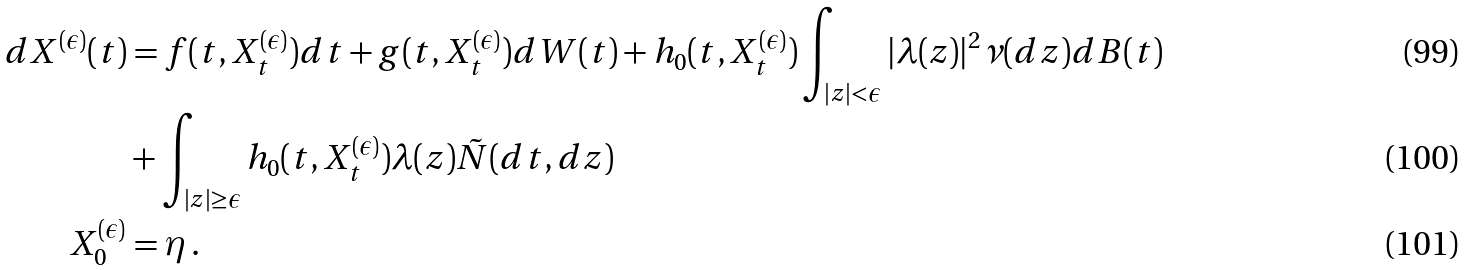<formula> <loc_0><loc_0><loc_500><loc_500>d X ^ { ( \epsilon ) } ( t ) & = f ( t , X ^ { ( \epsilon ) } _ { t } ) d t + g ( t , X ^ { ( \epsilon ) } _ { t } ) d W ( t ) + h _ { 0 } ( t , X ^ { ( \epsilon ) } _ { t } ) \int _ { | z | < \epsilon } | \lambda ( z ) | ^ { 2 } \nu ( d z ) d B ( t ) \\ & + \int _ { | z | \geq \epsilon } h _ { 0 } ( t , X ^ { ( \epsilon ) } _ { t } ) \lambda ( z ) \tilde { N } ( d t , d z ) \\ X ^ { ( \epsilon ) } _ { 0 } & = \eta \, .</formula> 